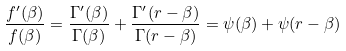Convert formula to latex. <formula><loc_0><loc_0><loc_500><loc_500>\frac { f ^ { \prime } ( \beta ) } { f ( \beta ) } = \frac { \Gamma ^ { \prime } ( \beta ) } { \Gamma ( \beta ) } + \frac { \Gamma ^ { \prime } ( r - \beta ) } { \Gamma ( r - \beta ) } = \psi ( \beta ) + \psi ( r - \beta )</formula> 